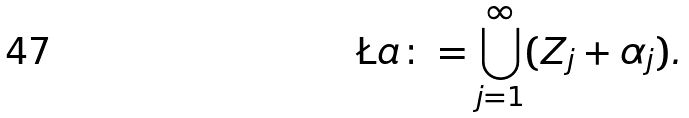Convert formula to latex. <formula><loc_0><loc_0><loc_500><loc_500>\L a \colon = \bigcup _ { j = 1 } ^ { \infty } ( Z _ { j } + \alpha _ { j } ) .</formula> 